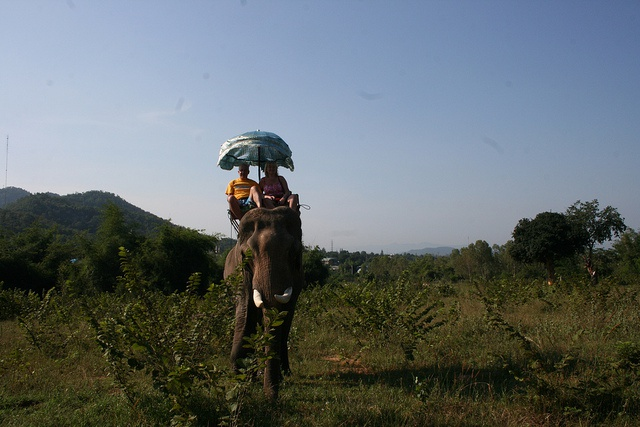Describe the objects in this image and their specific colors. I can see elephant in darkgray, black, olive, maroon, and gray tones, umbrella in darkgray, black, purple, gray, and darkblue tones, people in darkgray, black, maroon, brown, and tan tones, and people in darkgray, black, maroon, gray, and brown tones in this image. 